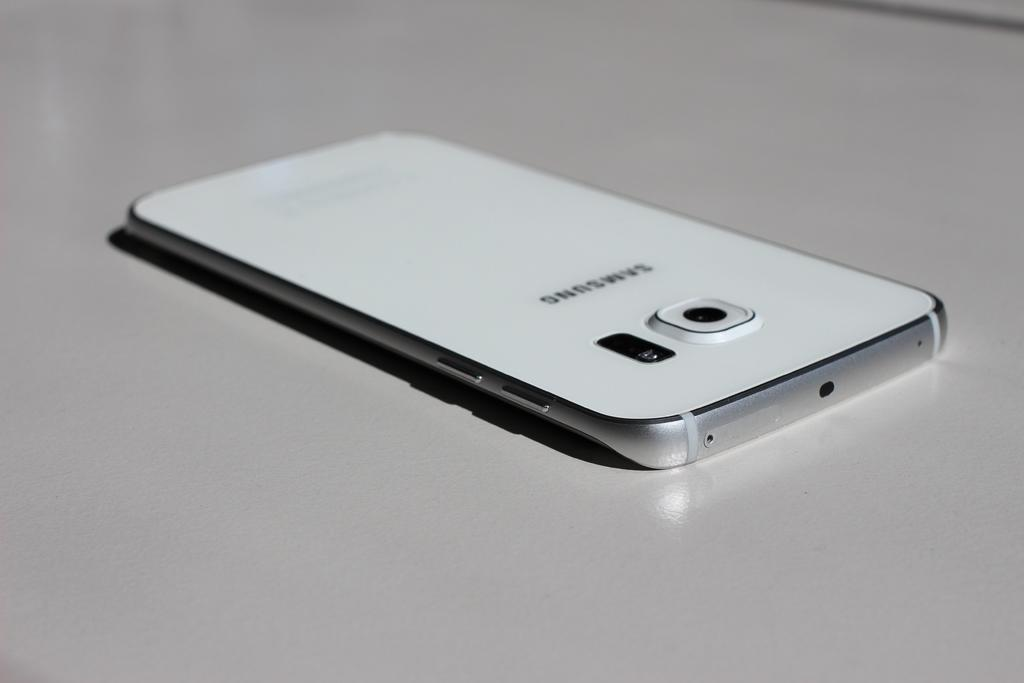<image>
Give a short and clear explanation of the subsequent image. A white Samsung cell phone is laying face down on a white surface. 